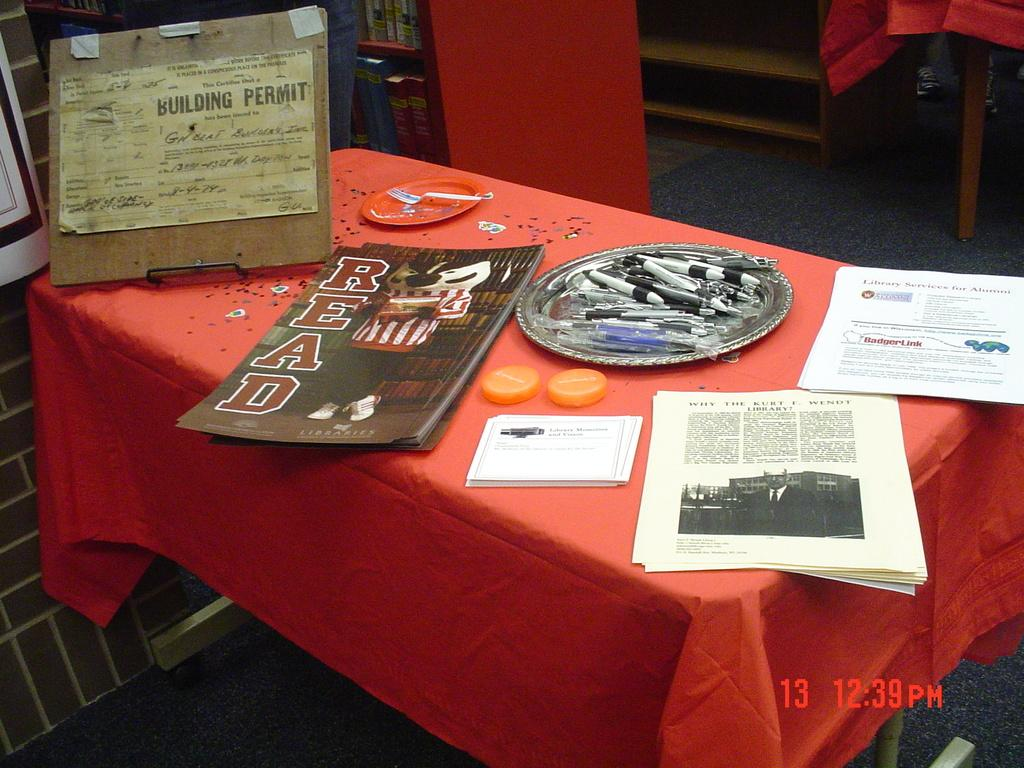Provide a one-sentence caption for the provided image. Posters advertising libraries are among the many items on this table. 